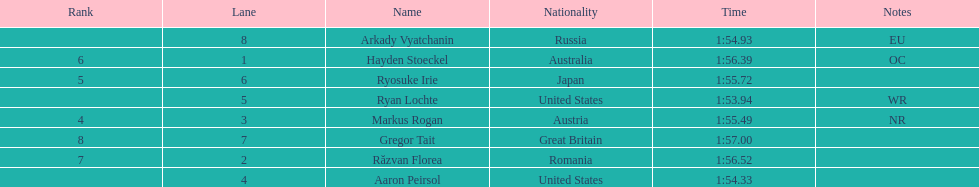How long did it take ryosuke irie to finish? 1:55.72. 